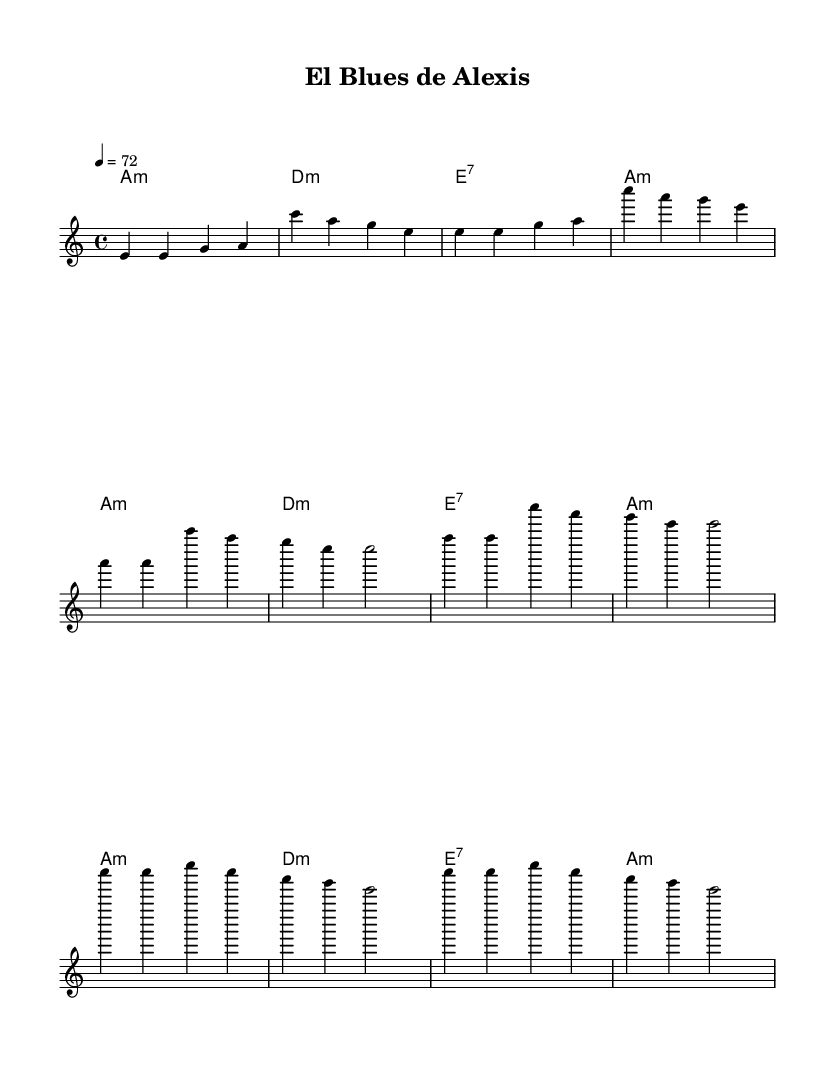What is the key signature of this music? The key signature is A minor, which is indicated by having no sharps or flats in the signature.
Answer: A minor What is the time signature of this piece? The time signature shown is 4/4, meaning there are four beats in each measure and a quarter note receives one beat.
Answer: 4/4 What is the tempo marking for this music? The tempo marking is indicated as 4 = 72, which means there are 72 beats per minute.
Answer: 72 How many measures are in the first verse? The first verse consists of four measures, as indicated by the grouping of the notes and chords.
Answer: 4 What type of chords are used in the harmonies? The chords used are primarily minor and dominant seventh chords, which are consistent with the Blues style.
Answer: Minor and dominant seventh What is the structure of the piece regarding verses and chorus? The structure alternates between a verse followed by a chorus, typical of Blues music.
Answer: Verse and chorus What is the highest note in the melody? The highest note in the melody is C, which can be seen in the upper part of the melody staff.
Answer: C 